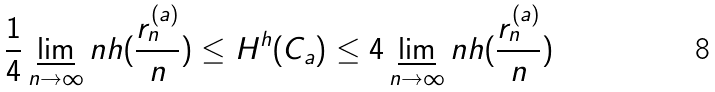<formula> <loc_0><loc_0><loc_500><loc_500>\frac { 1 } { 4 } \varliminf _ { n \rightarrow \infty } n h ( \frac { r _ { n } ^ { ( a ) } } { n } ) \leq H ^ { h } ( C _ { a } ) \leq 4 \varliminf _ { n \rightarrow \infty } n h ( \frac { r _ { n } ^ { ( a ) } } { n } )</formula> 